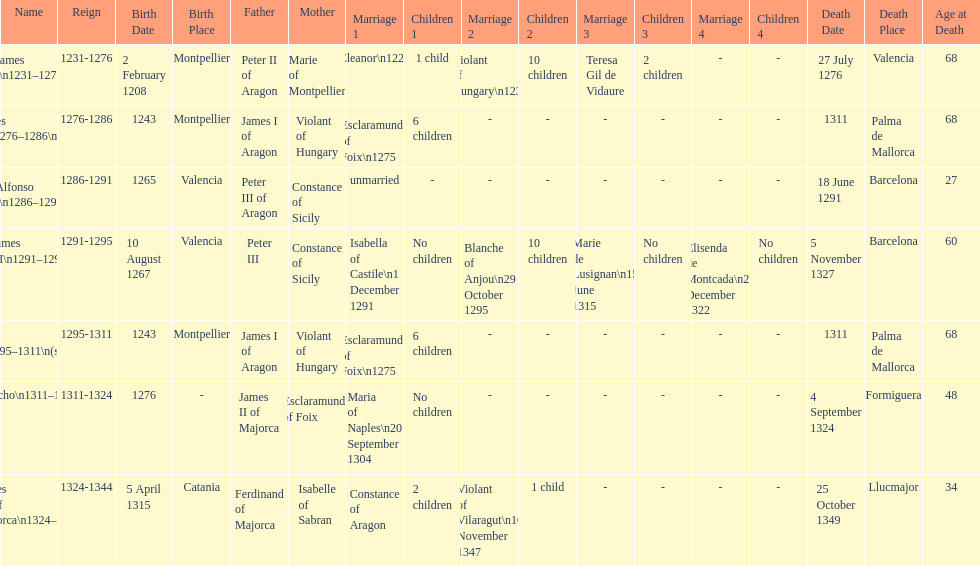How many of these monarchs died before the age of 65? 4. 